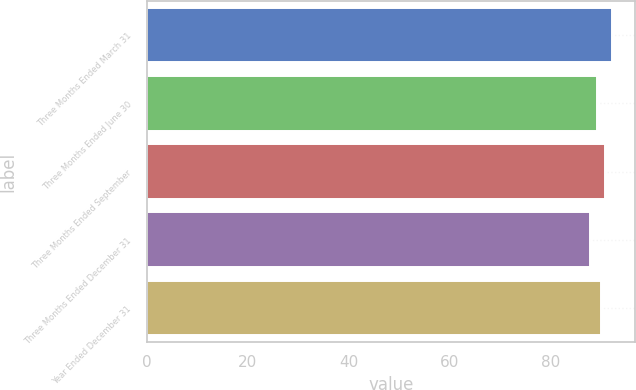Convert chart. <chart><loc_0><loc_0><loc_500><loc_500><bar_chart><fcel>Three Months Ended March 31<fcel>Three Months Ended June 30<fcel>Three Months Ended September<fcel>Three Months Ended December 31<fcel>Year Ended December 31<nl><fcel>92.2<fcel>89.2<fcel>90.8<fcel>87.8<fcel>90<nl></chart> 